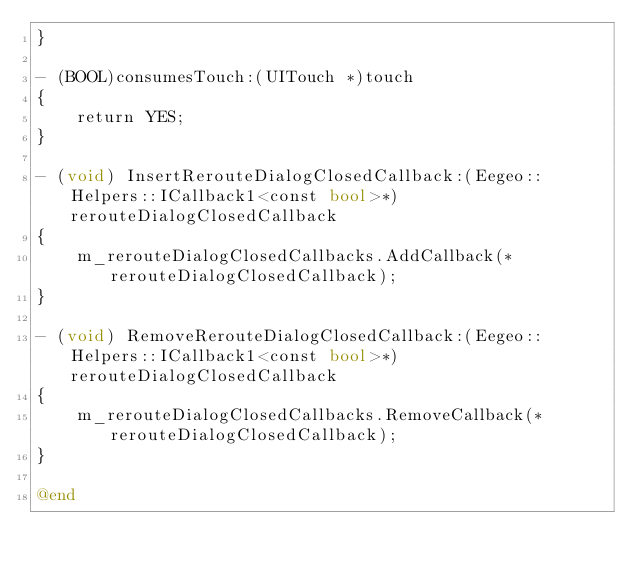Convert code to text. <code><loc_0><loc_0><loc_500><loc_500><_ObjectiveC_>}

- (BOOL)consumesTouch:(UITouch *)touch
{
    return YES;
}

- (void) InsertRerouteDialogClosedCallback:(Eegeo::Helpers::ICallback1<const bool>*) rerouteDialogClosedCallback
{
    m_rerouteDialogClosedCallbacks.AddCallback(*rerouteDialogClosedCallback);
}

- (void) RemoveRerouteDialogClosedCallback:(Eegeo::Helpers::ICallback1<const bool>*) rerouteDialogClosedCallback
{
    m_rerouteDialogClosedCallbacks.RemoveCallback(*rerouteDialogClosedCallback);
}

@end
</code> 